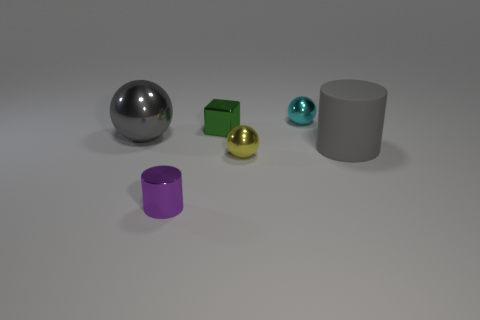Add 3 red cubes. How many objects exist? 9 Subtract all cubes. How many objects are left? 5 Subtract all tiny red metallic cylinders. Subtract all cubes. How many objects are left? 5 Add 3 large gray cylinders. How many large gray cylinders are left? 4 Add 3 tiny cyan rubber objects. How many tiny cyan rubber objects exist? 3 Subtract 0 brown balls. How many objects are left? 6 